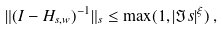Convert formula to latex. <formula><loc_0><loc_0><loc_500><loc_500>\| ( I - { H } _ { s , w } ) ^ { - 1 } \| _ { s } \leq \max ( 1 , | \Im s | ^ { \xi } ) \, ,</formula> 